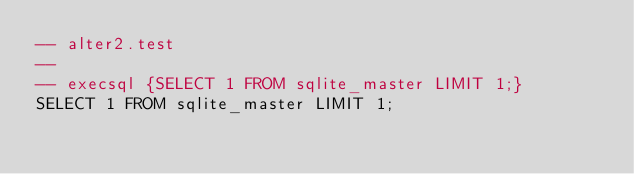Convert code to text. <code><loc_0><loc_0><loc_500><loc_500><_SQL_>-- alter2.test
-- 
-- execsql {SELECT 1 FROM sqlite_master LIMIT 1;}
SELECT 1 FROM sqlite_master LIMIT 1;</code> 